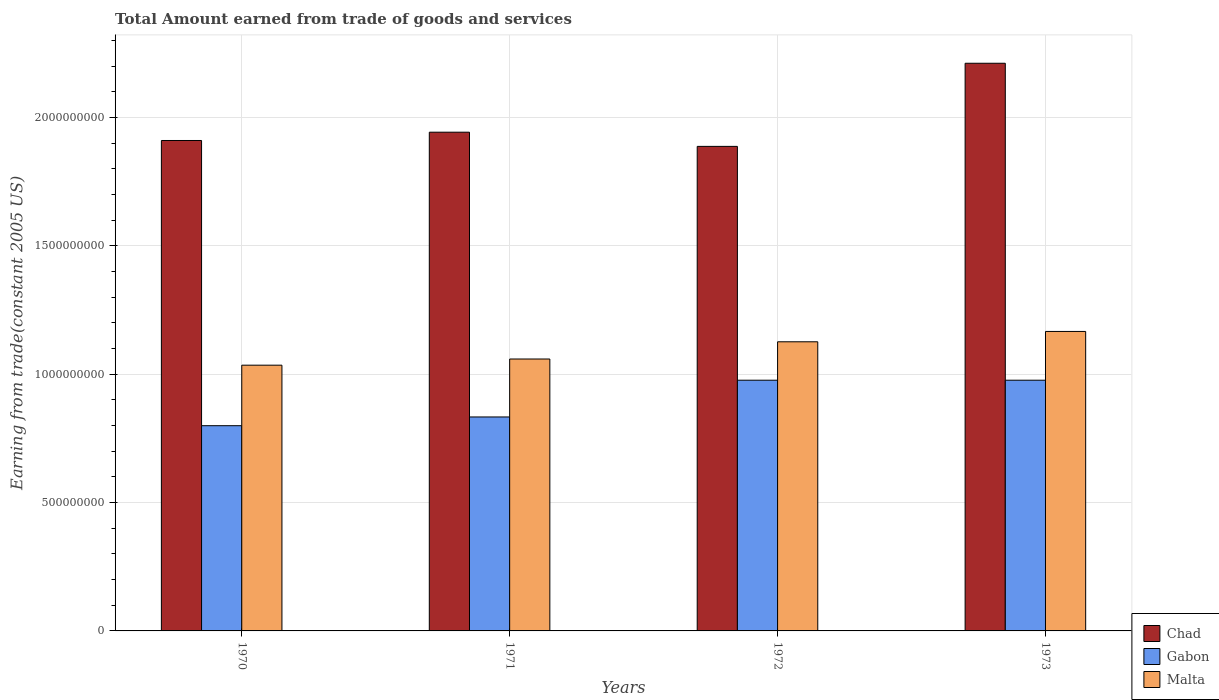Are the number of bars per tick equal to the number of legend labels?
Ensure brevity in your answer.  Yes. Are the number of bars on each tick of the X-axis equal?
Your response must be concise. Yes. How many bars are there on the 3rd tick from the left?
Make the answer very short. 3. In how many cases, is the number of bars for a given year not equal to the number of legend labels?
Give a very brief answer. 0. What is the total amount earned by trading goods and services in Gabon in 1970?
Offer a very short reply. 7.99e+08. Across all years, what is the maximum total amount earned by trading goods and services in Gabon?
Ensure brevity in your answer.  9.77e+08. Across all years, what is the minimum total amount earned by trading goods and services in Chad?
Offer a terse response. 1.89e+09. What is the total total amount earned by trading goods and services in Malta in the graph?
Your response must be concise. 4.39e+09. What is the difference between the total amount earned by trading goods and services in Chad in 1970 and that in 1971?
Give a very brief answer. -3.23e+07. What is the difference between the total amount earned by trading goods and services in Chad in 1973 and the total amount earned by trading goods and services in Malta in 1971?
Your response must be concise. 1.15e+09. What is the average total amount earned by trading goods and services in Malta per year?
Provide a short and direct response. 1.10e+09. In the year 1973, what is the difference between the total amount earned by trading goods and services in Gabon and total amount earned by trading goods and services in Malta?
Give a very brief answer. -1.90e+08. In how many years, is the total amount earned by trading goods and services in Gabon greater than 2000000000 US$?
Offer a very short reply. 0. What is the ratio of the total amount earned by trading goods and services in Malta in 1970 to that in 1973?
Offer a very short reply. 0.89. Is the difference between the total amount earned by trading goods and services in Gabon in 1972 and 1973 greater than the difference between the total amount earned by trading goods and services in Malta in 1972 and 1973?
Make the answer very short. Yes. What is the difference between the highest and the second highest total amount earned by trading goods and services in Gabon?
Your answer should be compact. 0. What is the difference between the highest and the lowest total amount earned by trading goods and services in Gabon?
Make the answer very short. 1.77e+08. Is the sum of the total amount earned by trading goods and services in Malta in 1971 and 1972 greater than the maximum total amount earned by trading goods and services in Gabon across all years?
Provide a succinct answer. Yes. What does the 3rd bar from the left in 1971 represents?
Offer a very short reply. Malta. What does the 1st bar from the right in 1973 represents?
Make the answer very short. Malta. Is it the case that in every year, the sum of the total amount earned by trading goods and services in Chad and total amount earned by trading goods and services in Gabon is greater than the total amount earned by trading goods and services in Malta?
Make the answer very short. Yes. Are all the bars in the graph horizontal?
Your answer should be compact. No. What is the difference between two consecutive major ticks on the Y-axis?
Your response must be concise. 5.00e+08. Where does the legend appear in the graph?
Ensure brevity in your answer.  Bottom right. How are the legend labels stacked?
Offer a terse response. Vertical. What is the title of the graph?
Offer a very short reply. Total Amount earned from trade of goods and services. What is the label or title of the X-axis?
Provide a short and direct response. Years. What is the label or title of the Y-axis?
Give a very brief answer. Earning from trade(constant 2005 US). What is the Earning from trade(constant 2005 US) in Chad in 1970?
Your response must be concise. 1.91e+09. What is the Earning from trade(constant 2005 US) in Gabon in 1970?
Make the answer very short. 7.99e+08. What is the Earning from trade(constant 2005 US) of Malta in 1970?
Offer a very short reply. 1.04e+09. What is the Earning from trade(constant 2005 US) in Chad in 1971?
Offer a terse response. 1.94e+09. What is the Earning from trade(constant 2005 US) of Gabon in 1971?
Your response must be concise. 8.33e+08. What is the Earning from trade(constant 2005 US) in Malta in 1971?
Offer a very short reply. 1.06e+09. What is the Earning from trade(constant 2005 US) in Chad in 1972?
Your answer should be compact. 1.89e+09. What is the Earning from trade(constant 2005 US) in Gabon in 1972?
Offer a very short reply. 9.77e+08. What is the Earning from trade(constant 2005 US) in Malta in 1972?
Give a very brief answer. 1.13e+09. What is the Earning from trade(constant 2005 US) of Chad in 1973?
Make the answer very short. 2.21e+09. What is the Earning from trade(constant 2005 US) in Gabon in 1973?
Make the answer very short. 9.77e+08. What is the Earning from trade(constant 2005 US) of Malta in 1973?
Offer a very short reply. 1.17e+09. Across all years, what is the maximum Earning from trade(constant 2005 US) of Chad?
Offer a very short reply. 2.21e+09. Across all years, what is the maximum Earning from trade(constant 2005 US) of Gabon?
Offer a terse response. 9.77e+08. Across all years, what is the maximum Earning from trade(constant 2005 US) in Malta?
Your response must be concise. 1.17e+09. Across all years, what is the minimum Earning from trade(constant 2005 US) of Chad?
Offer a very short reply. 1.89e+09. Across all years, what is the minimum Earning from trade(constant 2005 US) in Gabon?
Offer a terse response. 7.99e+08. Across all years, what is the minimum Earning from trade(constant 2005 US) in Malta?
Make the answer very short. 1.04e+09. What is the total Earning from trade(constant 2005 US) of Chad in the graph?
Ensure brevity in your answer.  7.95e+09. What is the total Earning from trade(constant 2005 US) of Gabon in the graph?
Ensure brevity in your answer.  3.59e+09. What is the total Earning from trade(constant 2005 US) of Malta in the graph?
Provide a succinct answer. 4.39e+09. What is the difference between the Earning from trade(constant 2005 US) in Chad in 1970 and that in 1971?
Ensure brevity in your answer.  -3.23e+07. What is the difference between the Earning from trade(constant 2005 US) in Gabon in 1970 and that in 1971?
Your response must be concise. -3.40e+07. What is the difference between the Earning from trade(constant 2005 US) in Malta in 1970 and that in 1971?
Provide a succinct answer. -2.41e+07. What is the difference between the Earning from trade(constant 2005 US) of Chad in 1970 and that in 1972?
Your answer should be very brief. 2.30e+07. What is the difference between the Earning from trade(constant 2005 US) in Gabon in 1970 and that in 1972?
Give a very brief answer. -1.77e+08. What is the difference between the Earning from trade(constant 2005 US) in Malta in 1970 and that in 1972?
Your response must be concise. -9.11e+07. What is the difference between the Earning from trade(constant 2005 US) of Chad in 1970 and that in 1973?
Provide a short and direct response. -3.01e+08. What is the difference between the Earning from trade(constant 2005 US) of Gabon in 1970 and that in 1973?
Your answer should be very brief. -1.77e+08. What is the difference between the Earning from trade(constant 2005 US) of Malta in 1970 and that in 1973?
Provide a short and direct response. -1.31e+08. What is the difference between the Earning from trade(constant 2005 US) in Chad in 1971 and that in 1972?
Your answer should be very brief. 5.53e+07. What is the difference between the Earning from trade(constant 2005 US) of Gabon in 1971 and that in 1972?
Your answer should be compact. -1.43e+08. What is the difference between the Earning from trade(constant 2005 US) in Malta in 1971 and that in 1972?
Your response must be concise. -6.70e+07. What is the difference between the Earning from trade(constant 2005 US) in Chad in 1971 and that in 1973?
Give a very brief answer. -2.68e+08. What is the difference between the Earning from trade(constant 2005 US) of Gabon in 1971 and that in 1973?
Provide a short and direct response. -1.43e+08. What is the difference between the Earning from trade(constant 2005 US) of Malta in 1971 and that in 1973?
Make the answer very short. -1.07e+08. What is the difference between the Earning from trade(constant 2005 US) of Chad in 1972 and that in 1973?
Make the answer very short. -3.24e+08. What is the difference between the Earning from trade(constant 2005 US) in Gabon in 1972 and that in 1973?
Make the answer very short. 0. What is the difference between the Earning from trade(constant 2005 US) in Malta in 1972 and that in 1973?
Offer a terse response. -4.03e+07. What is the difference between the Earning from trade(constant 2005 US) of Chad in 1970 and the Earning from trade(constant 2005 US) of Gabon in 1971?
Your response must be concise. 1.08e+09. What is the difference between the Earning from trade(constant 2005 US) in Chad in 1970 and the Earning from trade(constant 2005 US) in Malta in 1971?
Keep it short and to the point. 8.51e+08. What is the difference between the Earning from trade(constant 2005 US) in Gabon in 1970 and the Earning from trade(constant 2005 US) in Malta in 1971?
Your response must be concise. -2.60e+08. What is the difference between the Earning from trade(constant 2005 US) of Chad in 1970 and the Earning from trade(constant 2005 US) of Gabon in 1972?
Offer a terse response. 9.34e+08. What is the difference between the Earning from trade(constant 2005 US) in Chad in 1970 and the Earning from trade(constant 2005 US) in Malta in 1972?
Your response must be concise. 7.84e+08. What is the difference between the Earning from trade(constant 2005 US) in Gabon in 1970 and the Earning from trade(constant 2005 US) in Malta in 1972?
Provide a succinct answer. -3.27e+08. What is the difference between the Earning from trade(constant 2005 US) in Chad in 1970 and the Earning from trade(constant 2005 US) in Gabon in 1973?
Provide a short and direct response. 9.34e+08. What is the difference between the Earning from trade(constant 2005 US) in Chad in 1970 and the Earning from trade(constant 2005 US) in Malta in 1973?
Give a very brief answer. 7.44e+08. What is the difference between the Earning from trade(constant 2005 US) in Gabon in 1970 and the Earning from trade(constant 2005 US) in Malta in 1973?
Make the answer very short. -3.67e+08. What is the difference between the Earning from trade(constant 2005 US) of Chad in 1971 and the Earning from trade(constant 2005 US) of Gabon in 1972?
Your answer should be very brief. 9.66e+08. What is the difference between the Earning from trade(constant 2005 US) of Chad in 1971 and the Earning from trade(constant 2005 US) of Malta in 1972?
Keep it short and to the point. 8.16e+08. What is the difference between the Earning from trade(constant 2005 US) in Gabon in 1971 and the Earning from trade(constant 2005 US) in Malta in 1972?
Provide a succinct answer. -2.93e+08. What is the difference between the Earning from trade(constant 2005 US) in Chad in 1971 and the Earning from trade(constant 2005 US) in Gabon in 1973?
Your answer should be compact. 9.66e+08. What is the difference between the Earning from trade(constant 2005 US) of Chad in 1971 and the Earning from trade(constant 2005 US) of Malta in 1973?
Give a very brief answer. 7.76e+08. What is the difference between the Earning from trade(constant 2005 US) in Gabon in 1971 and the Earning from trade(constant 2005 US) in Malta in 1973?
Ensure brevity in your answer.  -3.33e+08. What is the difference between the Earning from trade(constant 2005 US) in Chad in 1972 and the Earning from trade(constant 2005 US) in Gabon in 1973?
Your response must be concise. 9.11e+08. What is the difference between the Earning from trade(constant 2005 US) in Chad in 1972 and the Earning from trade(constant 2005 US) in Malta in 1973?
Provide a short and direct response. 7.21e+08. What is the difference between the Earning from trade(constant 2005 US) of Gabon in 1972 and the Earning from trade(constant 2005 US) of Malta in 1973?
Provide a succinct answer. -1.90e+08. What is the average Earning from trade(constant 2005 US) of Chad per year?
Ensure brevity in your answer.  1.99e+09. What is the average Earning from trade(constant 2005 US) of Gabon per year?
Keep it short and to the point. 8.96e+08. What is the average Earning from trade(constant 2005 US) in Malta per year?
Provide a short and direct response. 1.10e+09. In the year 1970, what is the difference between the Earning from trade(constant 2005 US) of Chad and Earning from trade(constant 2005 US) of Gabon?
Give a very brief answer. 1.11e+09. In the year 1970, what is the difference between the Earning from trade(constant 2005 US) in Chad and Earning from trade(constant 2005 US) in Malta?
Keep it short and to the point. 8.75e+08. In the year 1970, what is the difference between the Earning from trade(constant 2005 US) of Gabon and Earning from trade(constant 2005 US) of Malta?
Keep it short and to the point. -2.36e+08. In the year 1971, what is the difference between the Earning from trade(constant 2005 US) in Chad and Earning from trade(constant 2005 US) in Gabon?
Give a very brief answer. 1.11e+09. In the year 1971, what is the difference between the Earning from trade(constant 2005 US) of Chad and Earning from trade(constant 2005 US) of Malta?
Provide a short and direct response. 8.83e+08. In the year 1971, what is the difference between the Earning from trade(constant 2005 US) in Gabon and Earning from trade(constant 2005 US) in Malta?
Provide a short and direct response. -2.26e+08. In the year 1972, what is the difference between the Earning from trade(constant 2005 US) in Chad and Earning from trade(constant 2005 US) in Gabon?
Give a very brief answer. 9.11e+08. In the year 1972, what is the difference between the Earning from trade(constant 2005 US) of Chad and Earning from trade(constant 2005 US) of Malta?
Offer a terse response. 7.61e+08. In the year 1972, what is the difference between the Earning from trade(constant 2005 US) of Gabon and Earning from trade(constant 2005 US) of Malta?
Give a very brief answer. -1.50e+08. In the year 1973, what is the difference between the Earning from trade(constant 2005 US) in Chad and Earning from trade(constant 2005 US) in Gabon?
Give a very brief answer. 1.23e+09. In the year 1973, what is the difference between the Earning from trade(constant 2005 US) of Chad and Earning from trade(constant 2005 US) of Malta?
Give a very brief answer. 1.04e+09. In the year 1973, what is the difference between the Earning from trade(constant 2005 US) of Gabon and Earning from trade(constant 2005 US) of Malta?
Provide a short and direct response. -1.90e+08. What is the ratio of the Earning from trade(constant 2005 US) of Chad in 1970 to that in 1971?
Provide a short and direct response. 0.98. What is the ratio of the Earning from trade(constant 2005 US) in Gabon in 1970 to that in 1971?
Offer a very short reply. 0.96. What is the ratio of the Earning from trade(constant 2005 US) of Malta in 1970 to that in 1971?
Ensure brevity in your answer.  0.98. What is the ratio of the Earning from trade(constant 2005 US) in Chad in 1970 to that in 1972?
Provide a succinct answer. 1.01. What is the ratio of the Earning from trade(constant 2005 US) of Gabon in 1970 to that in 1972?
Provide a succinct answer. 0.82. What is the ratio of the Earning from trade(constant 2005 US) of Malta in 1970 to that in 1972?
Offer a terse response. 0.92. What is the ratio of the Earning from trade(constant 2005 US) of Chad in 1970 to that in 1973?
Provide a succinct answer. 0.86. What is the ratio of the Earning from trade(constant 2005 US) of Gabon in 1970 to that in 1973?
Offer a terse response. 0.82. What is the ratio of the Earning from trade(constant 2005 US) in Malta in 1970 to that in 1973?
Your answer should be compact. 0.89. What is the ratio of the Earning from trade(constant 2005 US) of Chad in 1971 to that in 1972?
Your answer should be very brief. 1.03. What is the ratio of the Earning from trade(constant 2005 US) in Gabon in 1971 to that in 1972?
Keep it short and to the point. 0.85. What is the ratio of the Earning from trade(constant 2005 US) of Malta in 1971 to that in 1972?
Keep it short and to the point. 0.94. What is the ratio of the Earning from trade(constant 2005 US) in Chad in 1971 to that in 1973?
Make the answer very short. 0.88. What is the ratio of the Earning from trade(constant 2005 US) of Gabon in 1971 to that in 1973?
Ensure brevity in your answer.  0.85. What is the ratio of the Earning from trade(constant 2005 US) of Malta in 1971 to that in 1973?
Your answer should be very brief. 0.91. What is the ratio of the Earning from trade(constant 2005 US) in Chad in 1972 to that in 1973?
Offer a terse response. 0.85. What is the ratio of the Earning from trade(constant 2005 US) of Malta in 1972 to that in 1973?
Your response must be concise. 0.97. What is the difference between the highest and the second highest Earning from trade(constant 2005 US) of Chad?
Provide a short and direct response. 2.68e+08. What is the difference between the highest and the second highest Earning from trade(constant 2005 US) of Gabon?
Offer a terse response. 0. What is the difference between the highest and the second highest Earning from trade(constant 2005 US) in Malta?
Provide a succinct answer. 4.03e+07. What is the difference between the highest and the lowest Earning from trade(constant 2005 US) in Chad?
Offer a terse response. 3.24e+08. What is the difference between the highest and the lowest Earning from trade(constant 2005 US) of Gabon?
Your answer should be compact. 1.77e+08. What is the difference between the highest and the lowest Earning from trade(constant 2005 US) in Malta?
Provide a short and direct response. 1.31e+08. 